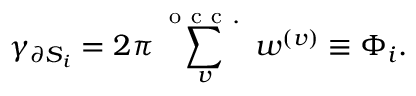<formula> <loc_0><loc_0><loc_500><loc_500>\gamma _ { \partial S _ { i } } = 2 \pi \sum _ { v } ^ { o c c . } w ^ { ( v ) } \equiv \Phi _ { i } .</formula> 